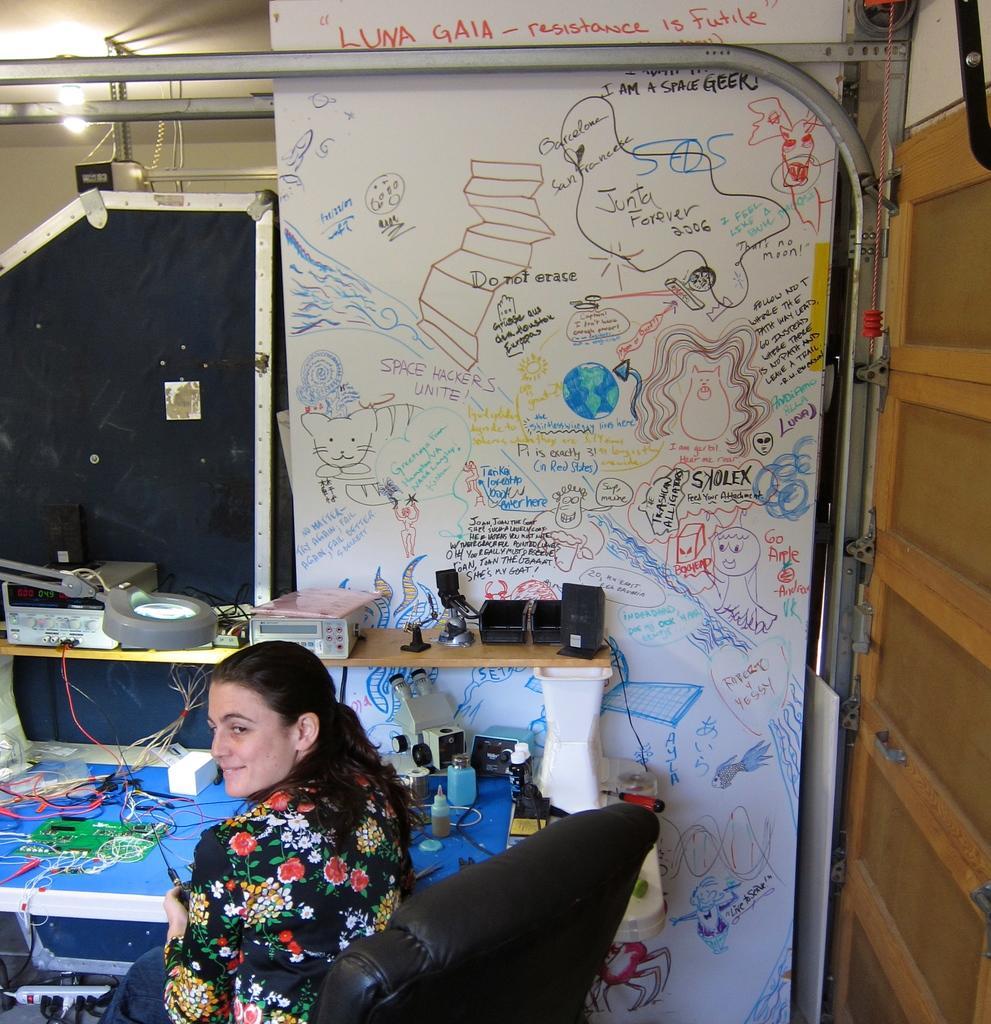Describe this image in one or two sentences. In this image I can see the person sitting on the chair. The person is wearing the colorful dress. In-front of the person I can see the blue color table. On the table I can see the wires, bottles and some electric objects can be seen. In the back there is a colorful board. I can also see the light in the top. 